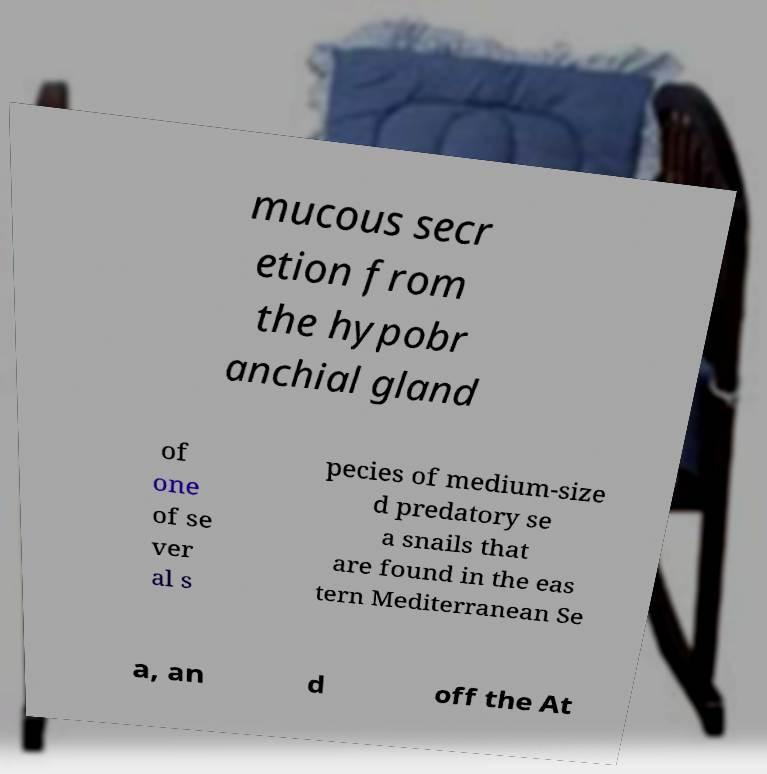I need the written content from this picture converted into text. Can you do that? mucous secr etion from the hypobr anchial gland of one of se ver al s pecies of medium-size d predatory se a snails that are found in the eas tern Mediterranean Se a, an d off the At 